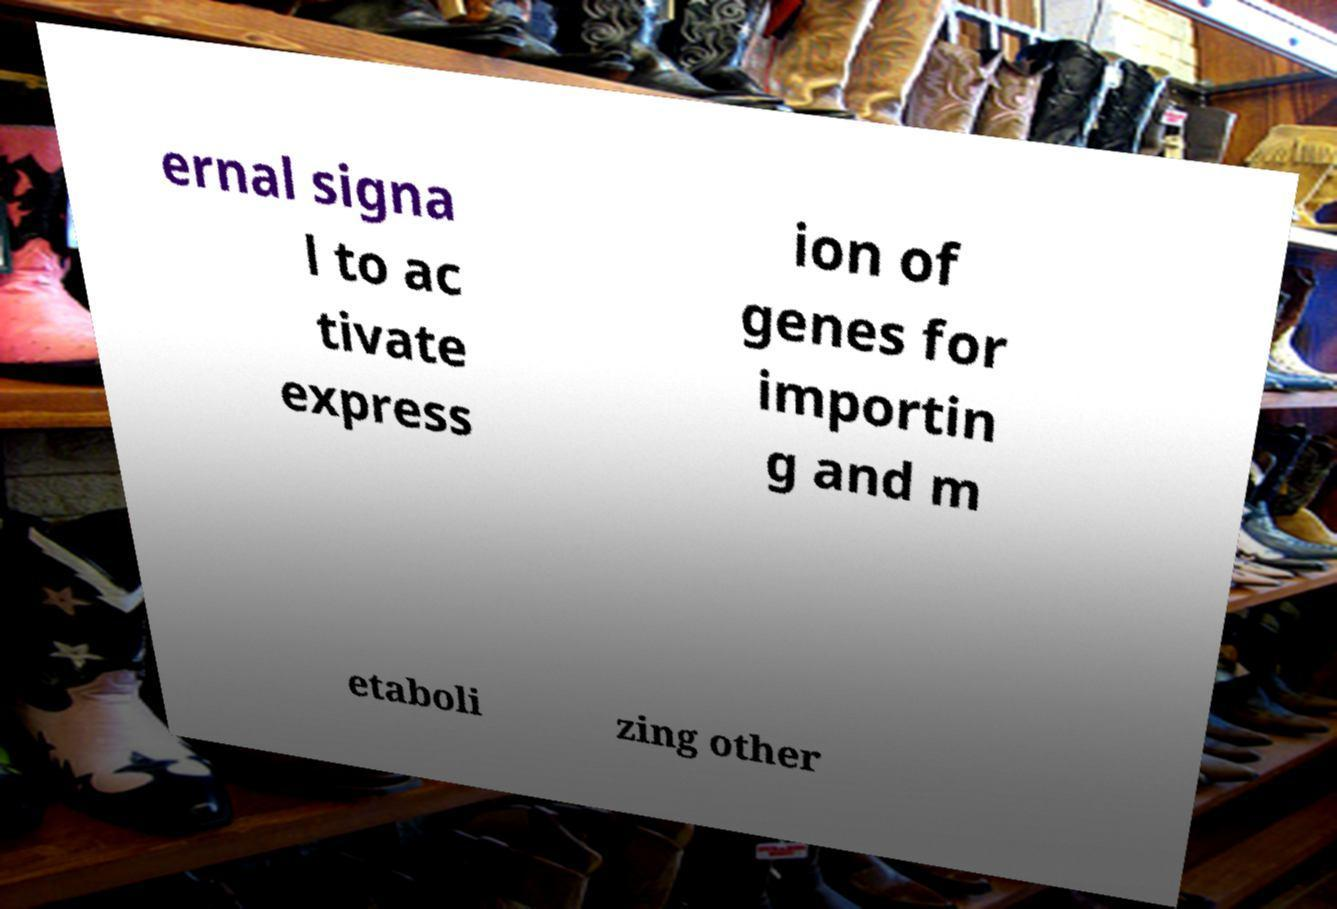Please read and relay the text visible in this image. What does it say? ernal signa l to ac tivate express ion of genes for importin g and m etaboli zing other 